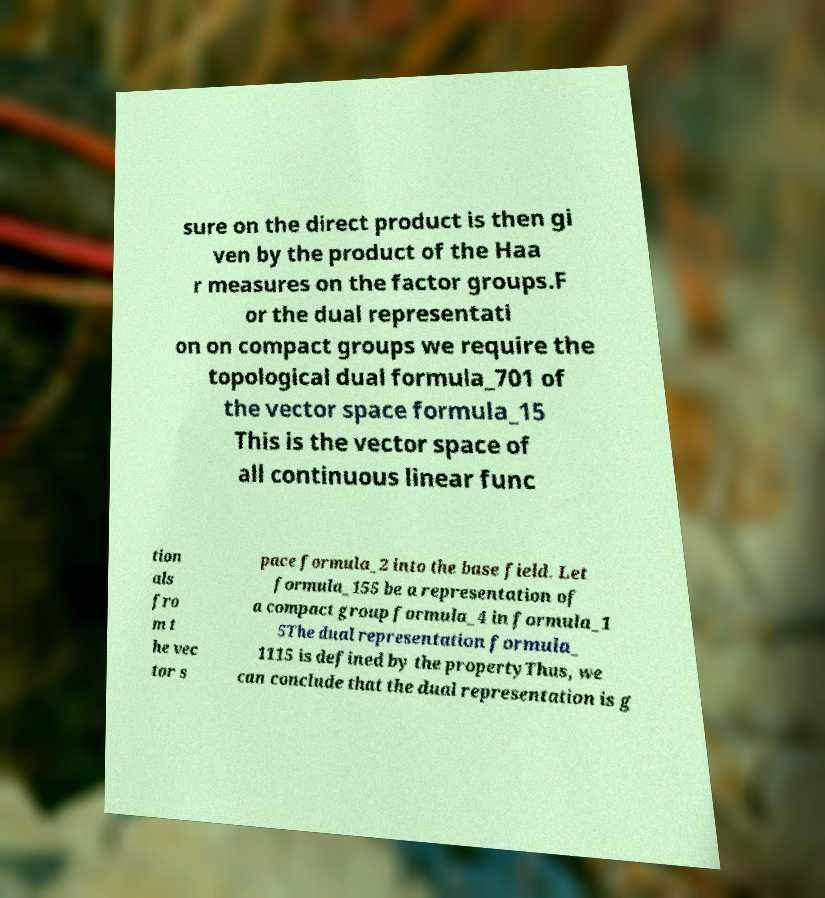Please identify and transcribe the text found in this image. sure on the direct product is then gi ven by the product of the Haa r measures on the factor groups.F or the dual representati on on compact groups we require the topological dual formula_701 of the vector space formula_15 This is the vector space of all continuous linear func tion als fro m t he vec tor s pace formula_2 into the base field. Let formula_155 be a representation of a compact group formula_4 in formula_1 5The dual representation formula_ 1115 is defined by the propertyThus, we can conclude that the dual representation is g 